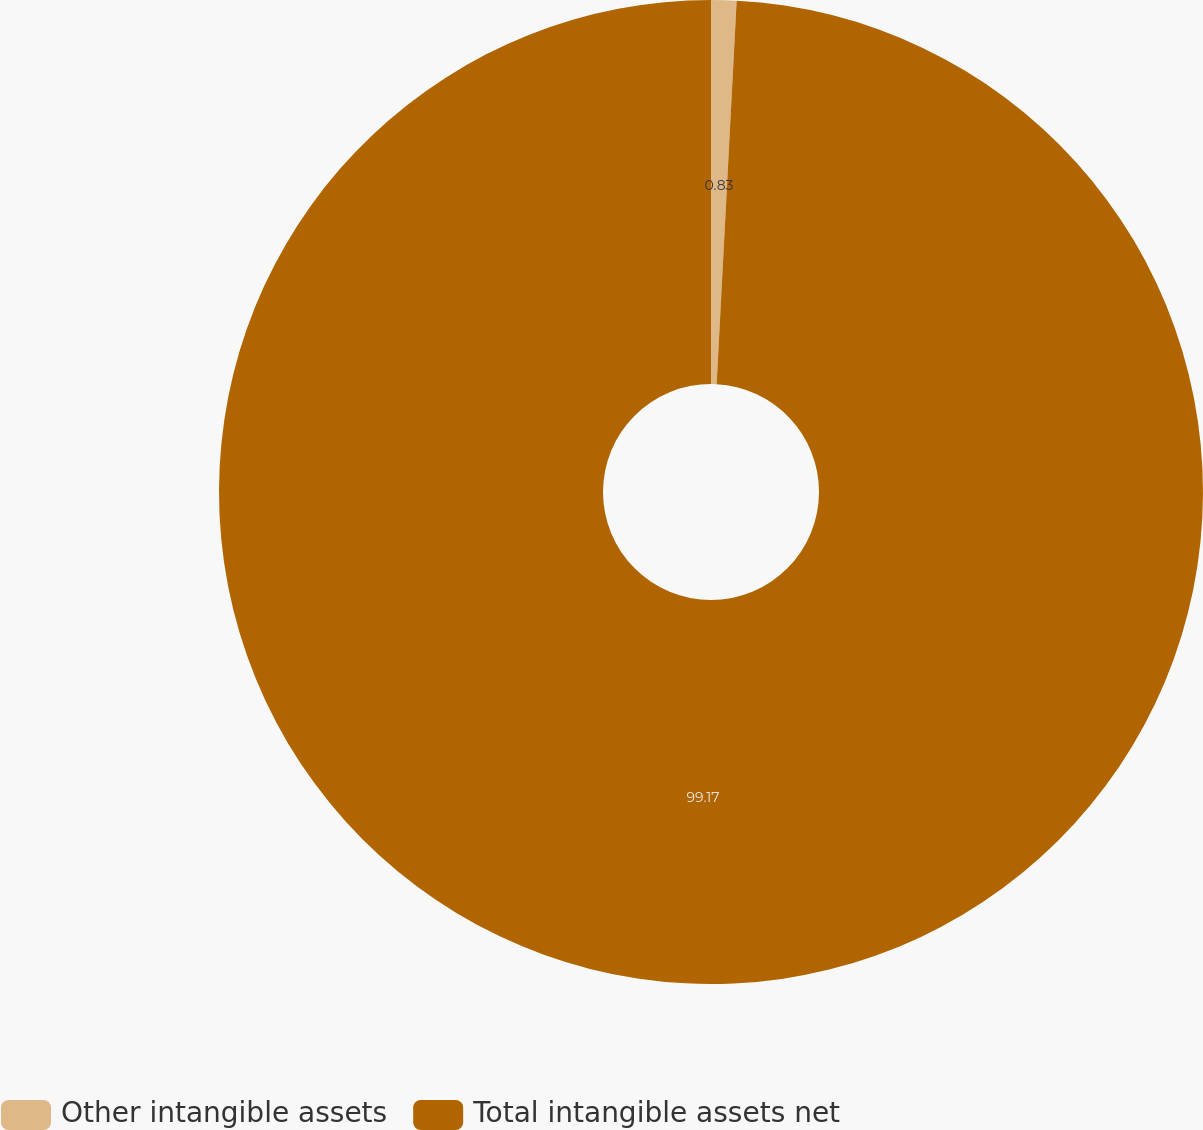Convert chart to OTSL. <chart><loc_0><loc_0><loc_500><loc_500><pie_chart><fcel>Other intangible assets<fcel>Total intangible assets net<nl><fcel>0.83%<fcel>99.17%<nl></chart> 